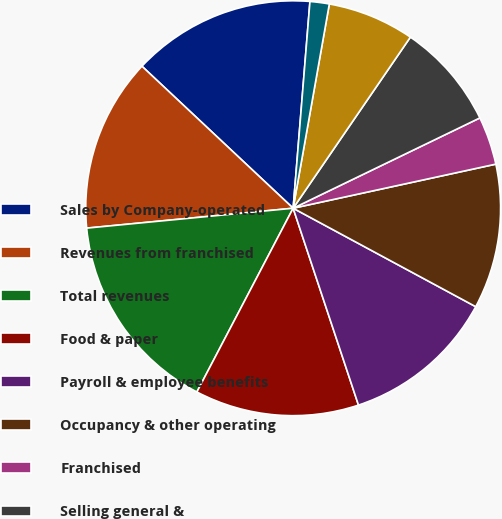Convert chart to OTSL. <chart><loc_0><loc_0><loc_500><loc_500><pie_chart><fcel>Sales by Company-operated<fcel>Revenues from franchised<fcel>Total revenues<fcel>Food & paper<fcel>Payroll & employee benefits<fcel>Occupancy & other operating<fcel>Franchised<fcel>Selling general &<fcel>Impairment and other charges<fcel>Other operating (income)<nl><fcel>14.29%<fcel>13.53%<fcel>15.79%<fcel>12.78%<fcel>12.03%<fcel>11.28%<fcel>3.76%<fcel>8.27%<fcel>6.77%<fcel>1.5%<nl></chart> 